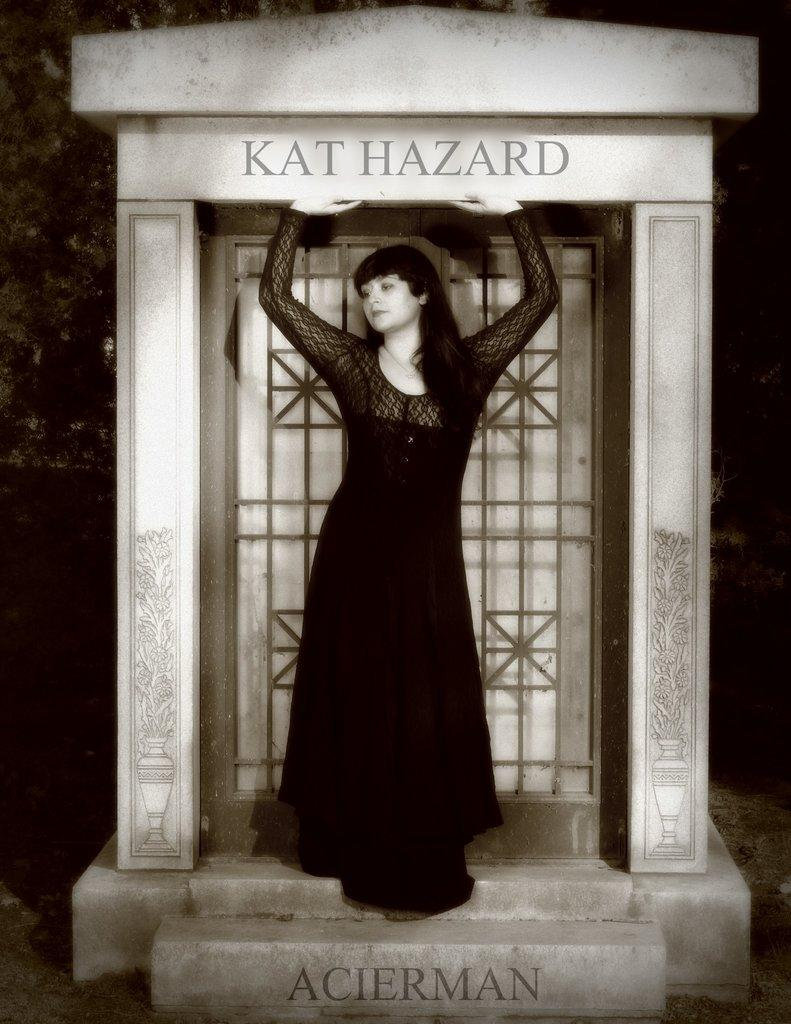What is the main subject of the image? There is a woman standing in the image. Is there any text present in the image? Yes, there is text written on the image. What is the color scheme of the image? The image is black and white in color. Can you see any houses in the image? There are no houses visible in the image; it features a woman standing and text written on it. Is there an earthquake happening in the image? There is no indication of an earthquake in the image; it is a black and white image of a woman standing and text written on it. 